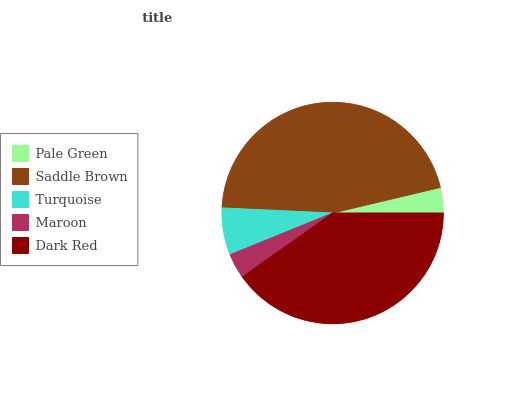Is Maroon the minimum?
Answer yes or no. Yes. Is Saddle Brown the maximum?
Answer yes or no. Yes. Is Turquoise the minimum?
Answer yes or no. No. Is Turquoise the maximum?
Answer yes or no. No. Is Saddle Brown greater than Turquoise?
Answer yes or no. Yes. Is Turquoise less than Saddle Brown?
Answer yes or no. Yes. Is Turquoise greater than Saddle Brown?
Answer yes or no. No. Is Saddle Brown less than Turquoise?
Answer yes or no. No. Is Turquoise the high median?
Answer yes or no. Yes. Is Turquoise the low median?
Answer yes or no. Yes. Is Maroon the high median?
Answer yes or no. No. Is Maroon the low median?
Answer yes or no. No. 